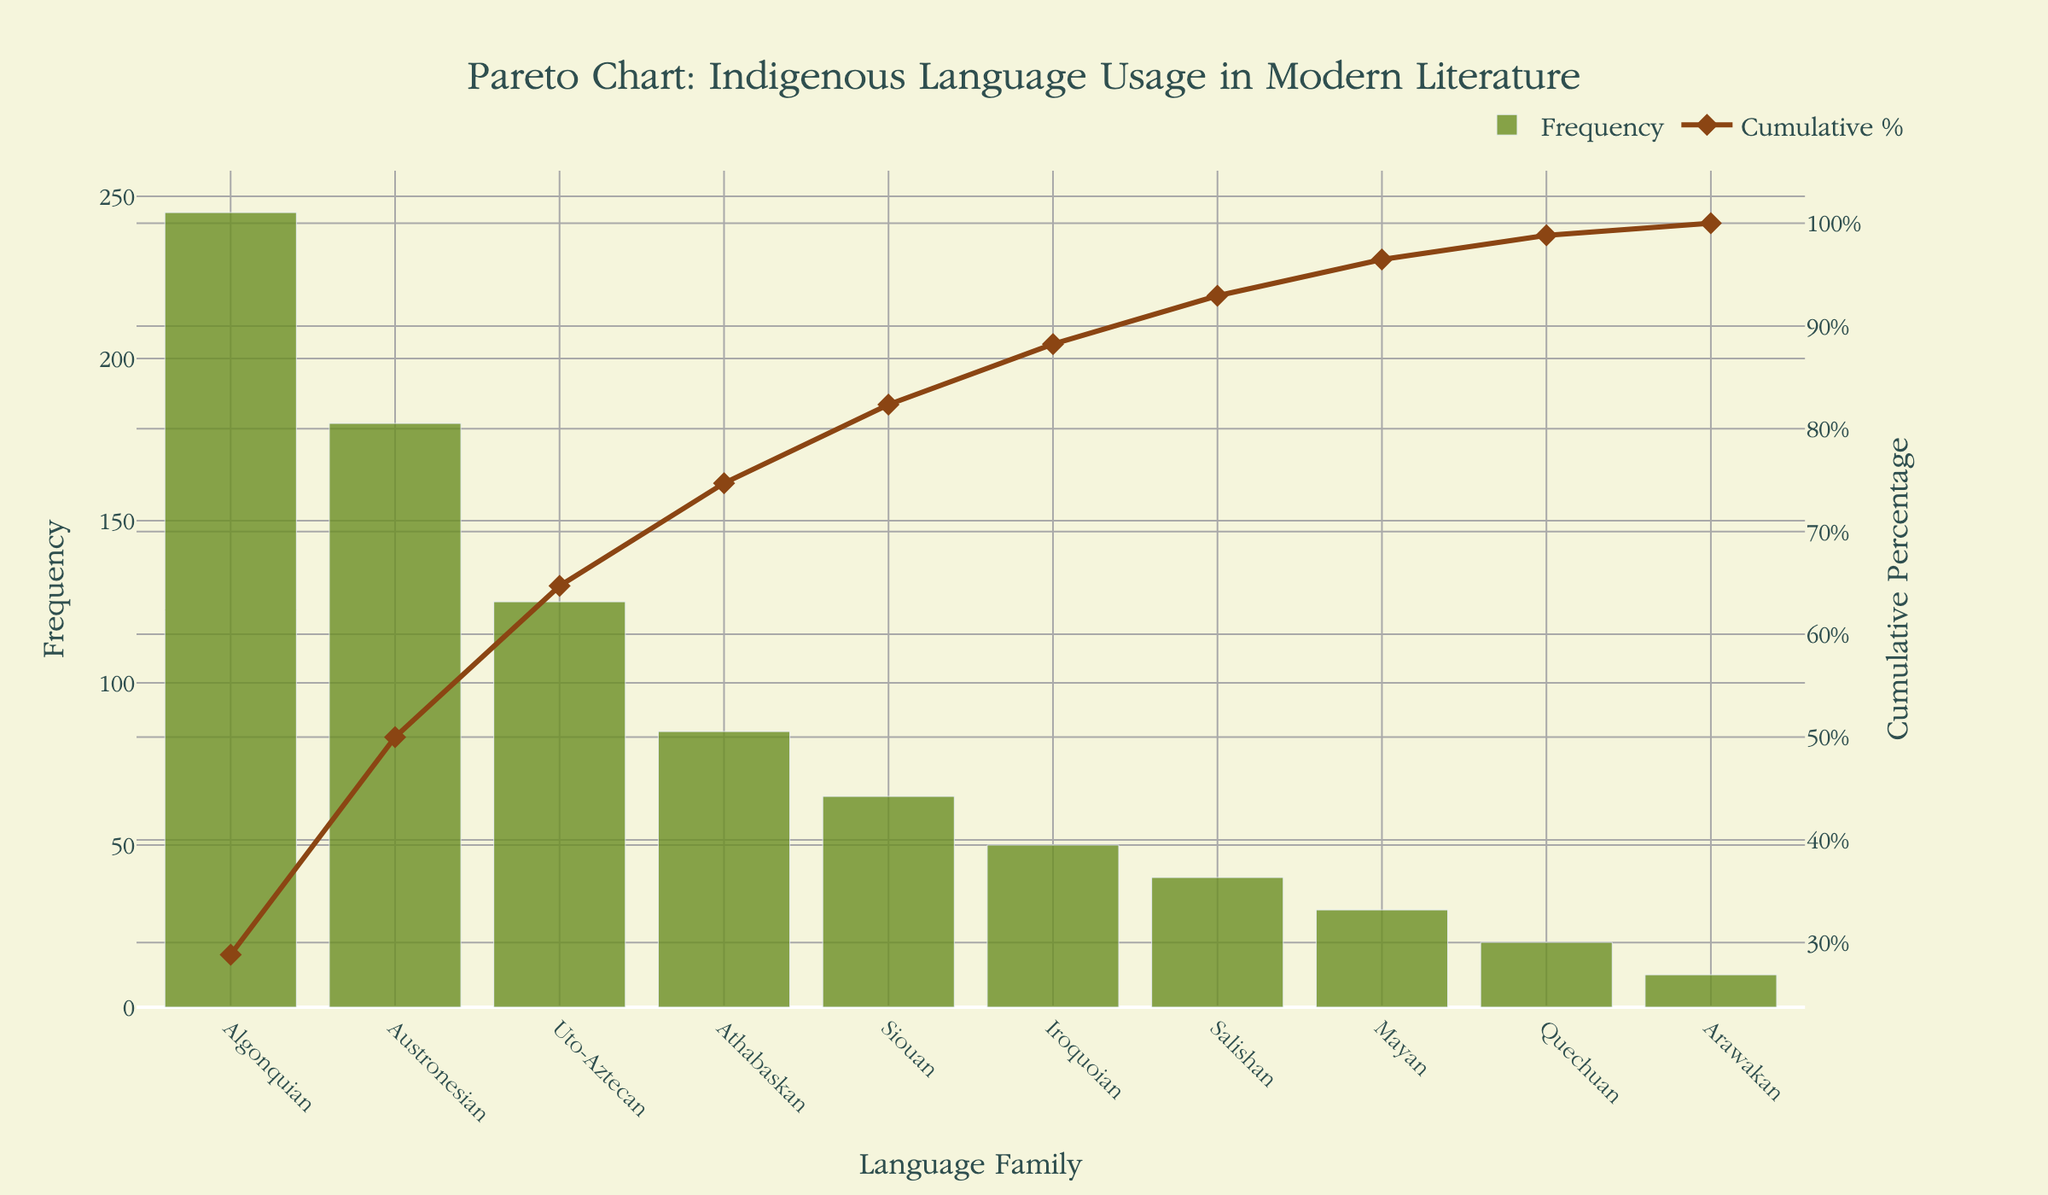What is the frequency of the Algonquian language family in modern literature? The frequency of the Algonquian language family can be observed directly from the bar plot in the Pareto chart. The bar for Algonquian peaks at 245.
Answer: 245 Which language families are responsible for 50% of the indigenous language usage in modern literature? By following the cumulative percentage line plot until it reaches 50%, we find that the Algonquian and Austronesian language families together reach this threshold.
Answer: Algonquian and Austronesian How many language families contribute to roughly 75% of the total language usage? By looking at the cumulative percentage plot, we see that the cumulative percentage reaches approximately 74.7% by the fifth language family, Athabaskan. Therefore, five language families contribute to roughly 75%.
Answer: 5 What is the cumulative percentage of the Siouan language family? The cumulative percentage for each language family is marked by the line plot. For the Siouan language family, it is 82.4%.
Answer: 82.4% Compare the frequency of the Uto-Aztecan and Mayan language families. Which one is higher and by how much? The frequency of the Uto-Aztecan language family is 125, while the Mayan language family has a frequency of 30. Subtracting these values shows that Uto-Aztecan is higher by 125 - 30 = 95.
Answer: Uto-Aztecan is higher by 95 What is the range of frequency values for the language families shown in the figure? The range of a data set is found by subtracting the smallest value from the largest. Here, the largest frequency is for Algonquian with 245, and the smallest is for Arawakan with 10. So, 245 - 10 = 235.
Answer: 235 Which language family marks the 90% cumulative percentage threshold? By following the cumulative percentage line, we see that the cumulative percentage at around 90% falls between Salishan (92.9%) and Iroquoian (88.2%). Hence, Iroquoian would mark the threshold just before 90%.
Answer: Iroquoian How does the frequency of Athabaskan compare to that of Salishan? The bar for Athabaskan hits 85, and the bar for Salishan reaches 40. Therefore, Athabaskan's frequency is more than double that of Salishan.
Answer: Athabaskan is more than double If the frequencies were categorized into "High", "Medium" and "Low" with thresholds at 100 and 50, how many language families fall into each category? By categorizing:
- "High" (Frequency > 100): Algonquian, Austronesian, and Uto-Aztecan (3).
- "Medium" (50 < Frequency <= 100): Athabaskan, Siouan, and Iroquoian (3).
- "Low" (Frequency <= 50): Salishan, Mayan, Quechuan, and Arawakan (4).
Answer: High: 3, Medium: 3, Low: 4 